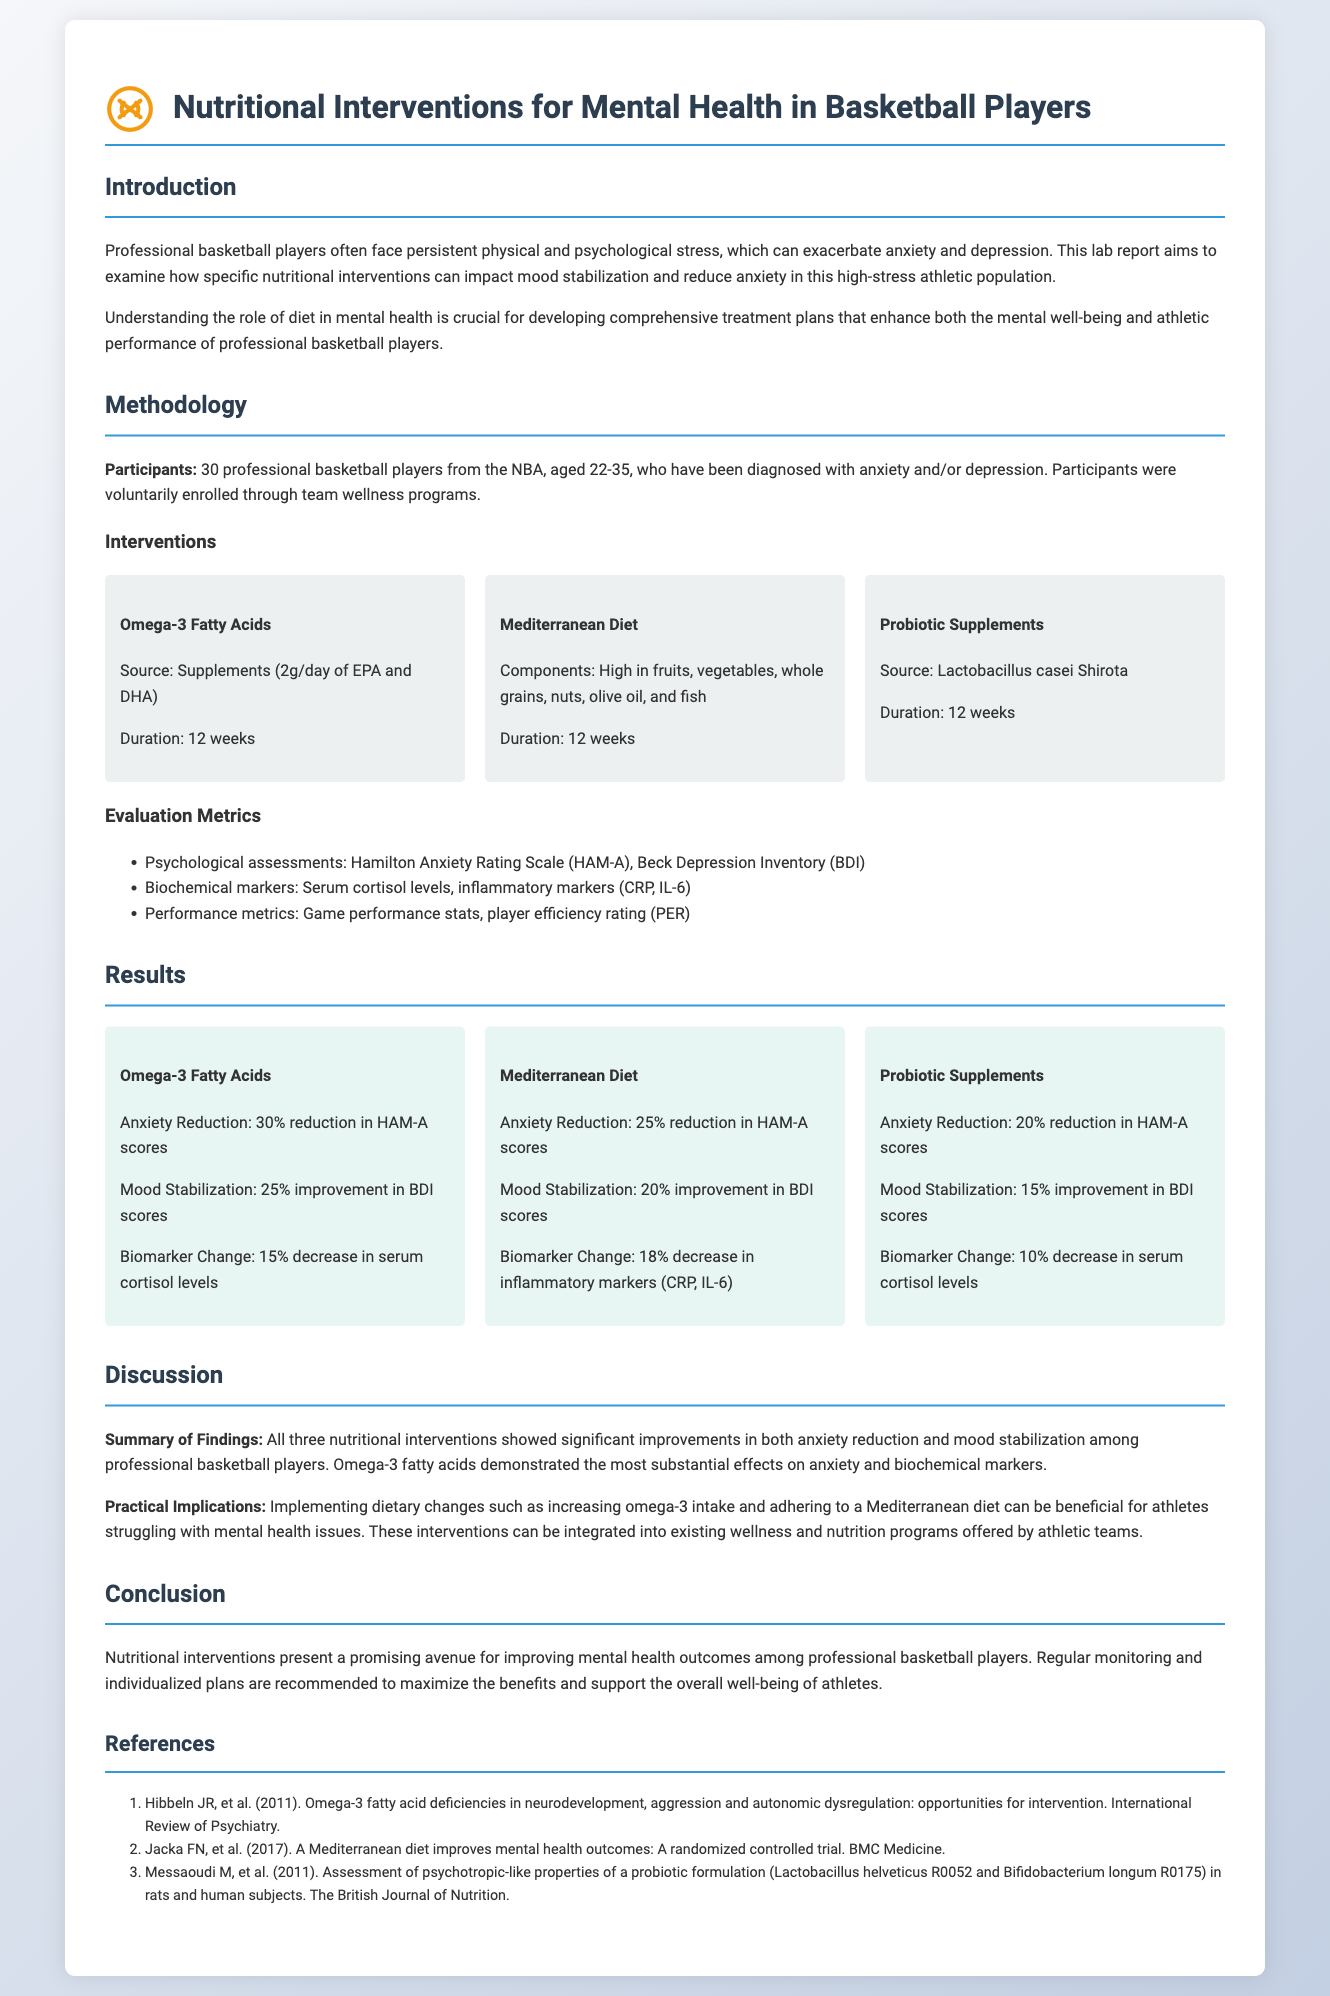What is the age range of the participants? The age range of the participants is mentioned in the document as 22-35 years.
Answer: 22-35 How long did the interventions last? The duration for all interventions is stated as 12 weeks in the document.
Answer: 12 weeks What is the method used to assess anxiety in participants? The document specifies using the Hamilton Anxiety Rating Scale (HAM-A) to assess anxiety.
Answer: Hamilton Anxiety Rating Scale Which intervention showed the highest percent reduction in anxiety scores? The Omega-3 Fatty Acids intervention showed a 30% reduction in HAM-A scores, which is the highest among the interventions.
Answer: Omega-3 Fatty Acids What were the two key psychological assessments used? The document lists the Hamilton Anxiety Rating Scale (HAM-A) and Beck Depression Inventory (BDI) as key psychological assessments.
Answer: Hamilton Anxiety Rating Scale and Beck Depression Inventory Which dietary intervention showed the most significant improvement in mood stabilization? The Omega-3 Fatty Acids intervention displayed a 25% improvement in BDI scores, indicating the most significant effect on mood stabilization.
Answer: Omega-3 Fatty Acids What was a practical implication of the findings? The practical implication highlighted in the document is that dietary changes such as increasing omega-3 intake can be beneficial for mental health.
Answer: Increasing omega-3 intake How much did serum cortisol levels decrease with Omega-3 intervention? The document states there was a 15% decrease in serum cortisol levels with Omega-3 supplementation.
Answer: 15% What was the main focus of the discussed lab report? The primary focus of the lab report is to evaluate the effectiveness of dietary changes on mood stabilization and anxiety reduction.
Answer: Evaluate nutritional interventions for mental health 